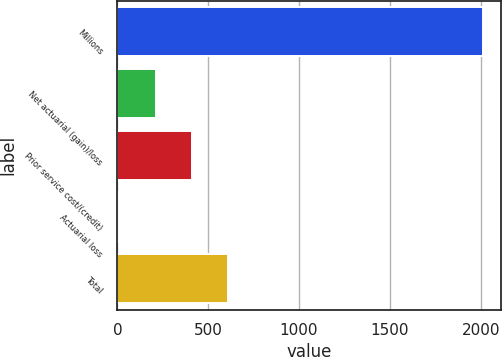Convert chart. <chart><loc_0><loc_0><loc_500><loc_500><bar_chart><fcel>Millions<fcel>Net actuarial (gain)/loss<fcel>Prior service cost/(credit)<fcel>Actuarial loss<fcel>Total<nl><fcel>2011<fcel>211<fcel>411<fcel>11<fcel>611<nl></chart> 